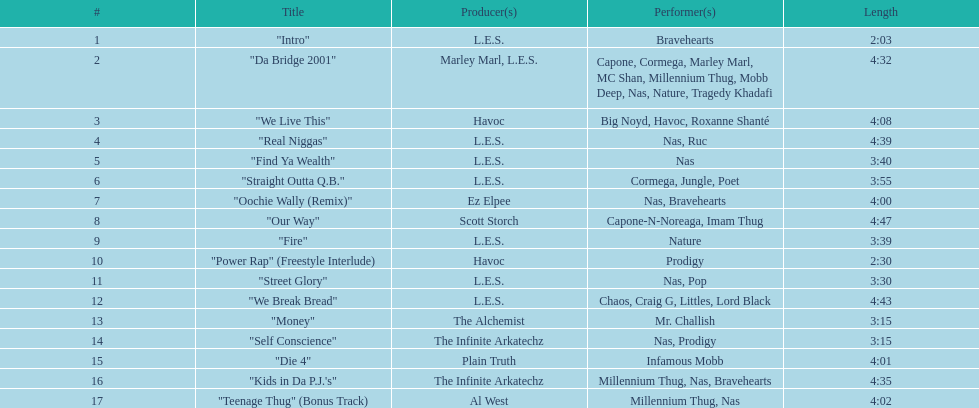What are the song lengths on the nas & ill will records presents qb's finest album? 2:03, 4:32, 4:08, 4:39, 3:40, 3:55, 4:00, 4:47, 3:39, 2:30, 3:30, 4:43, 3:15, 3:15, 4:01, 4:35, 4:02. Among them, which is the lengthiest? 4:47. 